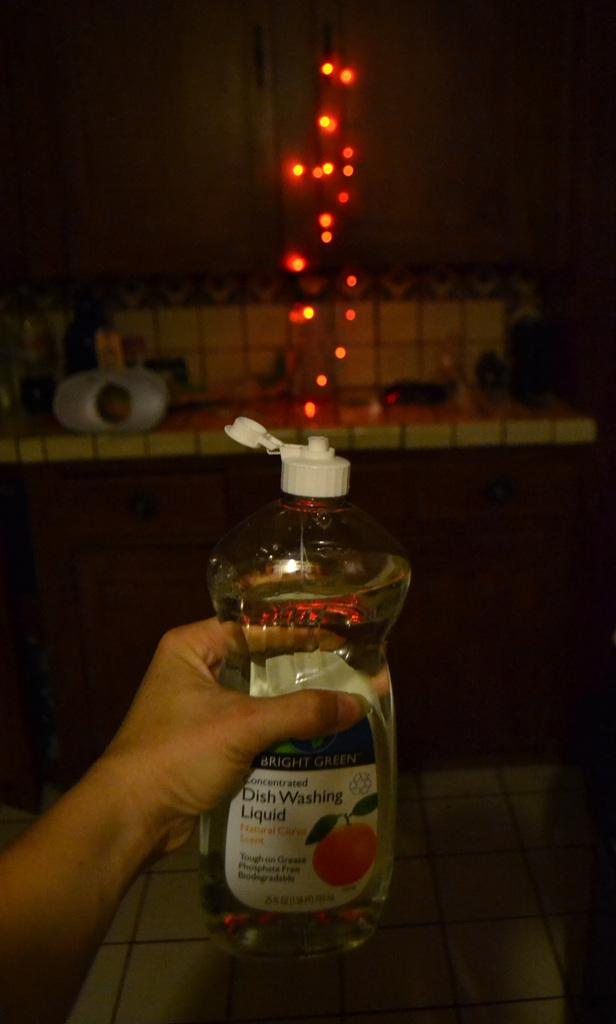What is the human hand holding in the image? The human hand is holding a bottle in the image. What type of liquid is in the bottle? The bottle is labeled as "Washing Liquid". What can be seen in the background of the image? There is a cupboard, a light, and a table in the background of the image. Where is the daughter sleeping in the image? There is no daughter or sleeping area present in the image. What type of branch is growing from the table in the image? There is no branch growing from the table in the image. 